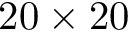Convert formula to latex. <formula><loc_0><loc_0><loc_500><loc_500>2 0 \times 2 0</formula> 